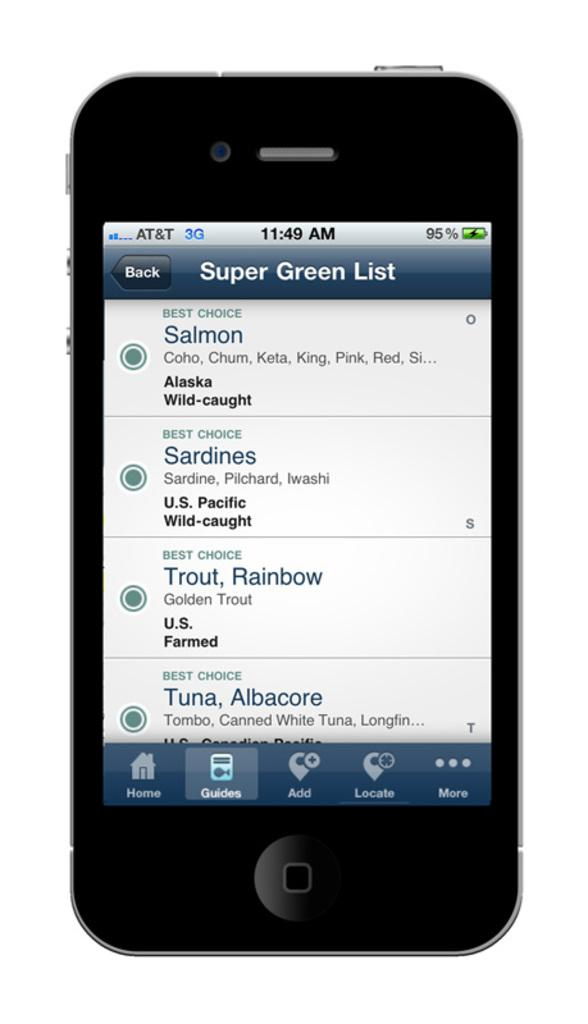<image>
Create a compact narrative representing the image presented. Four different types of fish including Salmon and Sardines are on a touch screen cell phone with in formation like their type and origin. 